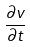Convert formula to latex. <formula><loc_0><loc_0><loc_500><loc_500>\frac { \partial v } { \partial t }</formula> 